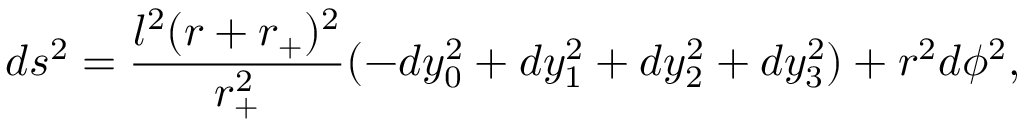<formula> <loc_0><loc_0><loc_500><loc_500>d s ^ { 2 } = \frac { l ^ { 2 } ( r + r _ { + } ) ^ { 2 } } { r _ { + } ^ { 2 } } ( - d y _ { 0 } ^ { 2 } + d y _ { 1 } ^ { 2 } + d y _ { 2 } ^ { 2 } + d y _ { 3 } ^ { 2 } ) + r ^ { 2 } d \phi ^ { 2 } ,</formula> 